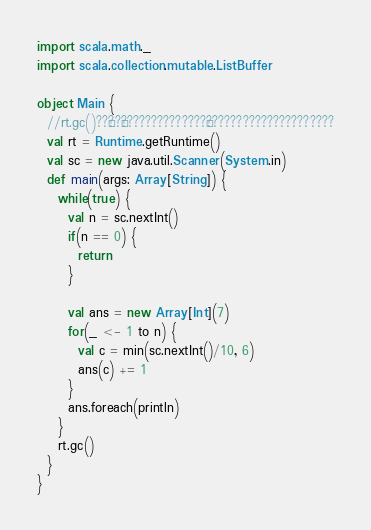<code> <loc_0><loc_0><loc_500><loc_500><_Scala_>import scala.math._
import scala.collection.mutable.ListBuffer

object Main {
  //rt.gc()??§??¬??????????????¬?????????????????????
  val rt = Runtime.getRuntime()
  val sc = new java.util.Scanner(System.in)
  def main(args: Array[String]) {
    while(true) {
      val n = sc.nextInt()
      if(n == 0) {
        return
      }

      val ans = new Array[Int](7)
      for(_ <- 1 to n) {
        val c = min(sc.nextInt()/10, 6)
        ans(c) += 1
      }
      ans.foreach(println)
    }
    rt.gc()
  }
}</code> 